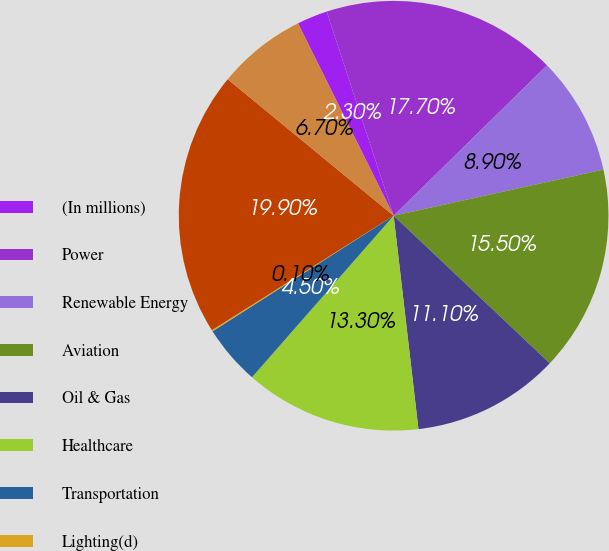Convert chart to OTSL. <chart><loc_0><loc_0><loc_500><loc_500><pie_chart><fcel>(In millions)<fcel>Power<fcel>Renewable Energy<fcel>Aviation<fcel>Oil & Gas<fcel>Healthcare<fcel>Transportation<fcel>Lighting(d)<fcel>Capital(e)<fcel>Corporate items and<nl><fcel>2.3%<fcel>17.7%<fcel>8.9%<fcel>15.5%<fcel>11.1%<fcel>13.3%<fcel>4.5%<fcel>0.1%<fcel>19.9%<fcel>6.7%<nl></chart> 